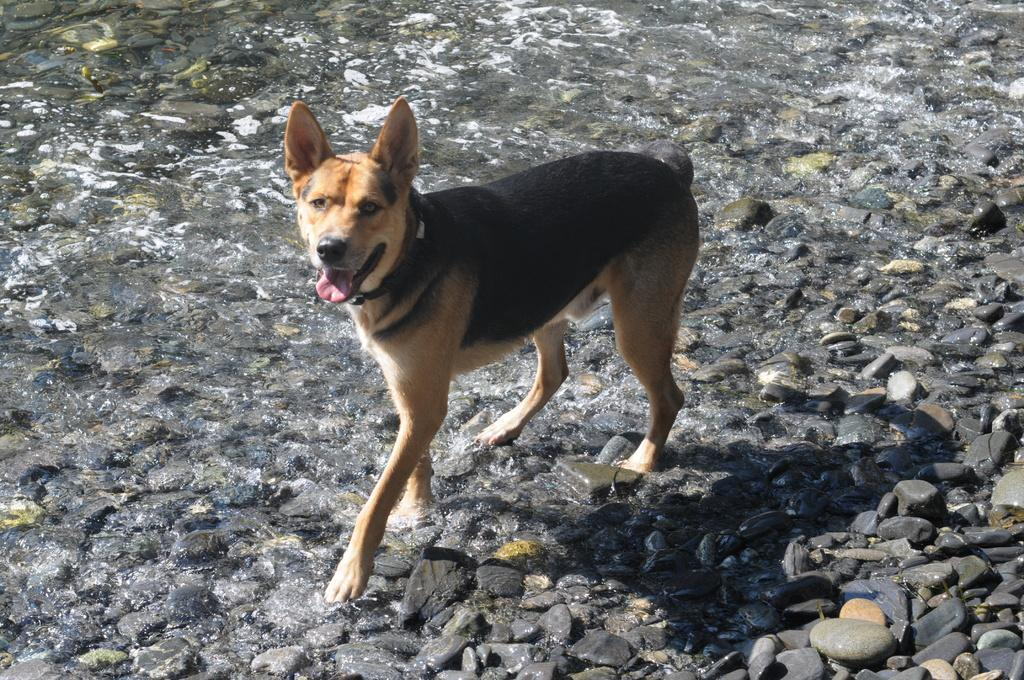What type of animal is in the image? There is a dog in the image. Can you describe the dog's appearance? The dog is brown and black in color. What type of terrain is visible in the image? There are stones visible in the image. What else can be seen in the image besides the dog and stones? There is water visible in the image. How does the crowd react to the dog's leg in the image? There is no crowd present in the image, and the dog's leg is not a focus of the image. 